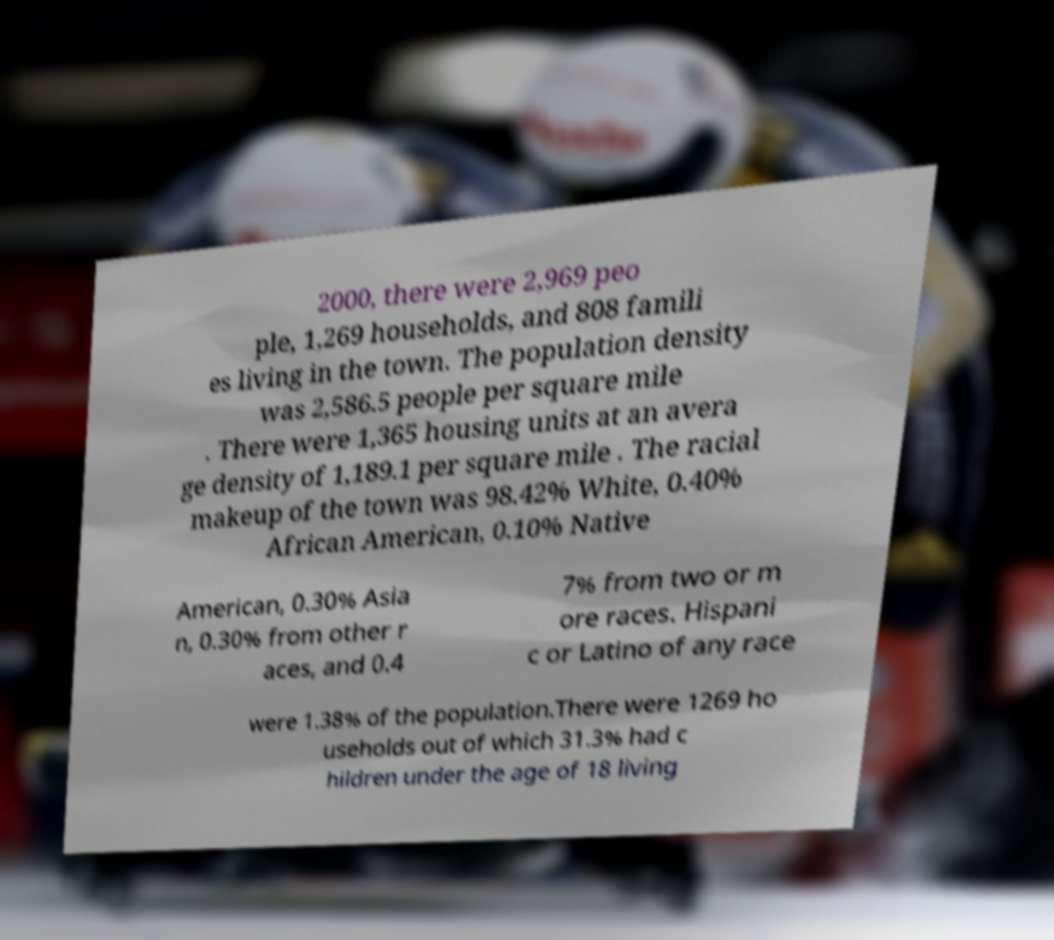Can you read and provide the text displayed in the image?This photo seems to have some interesting text. Can you extract and type it out for me? 2000, there were 2,969 peo ple, 1,269 households, and 808 famili es living in the town. The population density was 2,586.5 people per square mile . There were 1,365 housing units at an avera ge density of 1,189.1 per square mile . The racial makeup of the town was 98.42% White, 0.40% African American, 0.10% Native American, 0.30% Asia n, 0.30% from other r aces, and 0.4 7% from two or m ore races. Hispani c or Latino of any race were 1.38% of the population.There were 1269 ho useholds out of which 31.3% had c hildren under the age of 18 living 